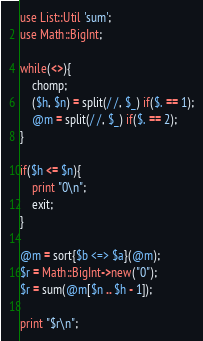<code> <loc_0><loc_0><loc_500><loc_500><_Perl_>use List::Util 'sum';
use Math::BigInt;

while(<>){
	chomp;
	($h, $n) = split(/ /, $_) if($. == 1);
	@m = split(/ /, $_) if($. == 2);
}

if($h <= $n){
	print "0\n";
	exit;
}

@m = sort{$b <=> $a}(@m);
$r = Math::BigInt->new("0");
$r = sum(@m[$n .. $h - 1]);

print "$r\n";

</code> 